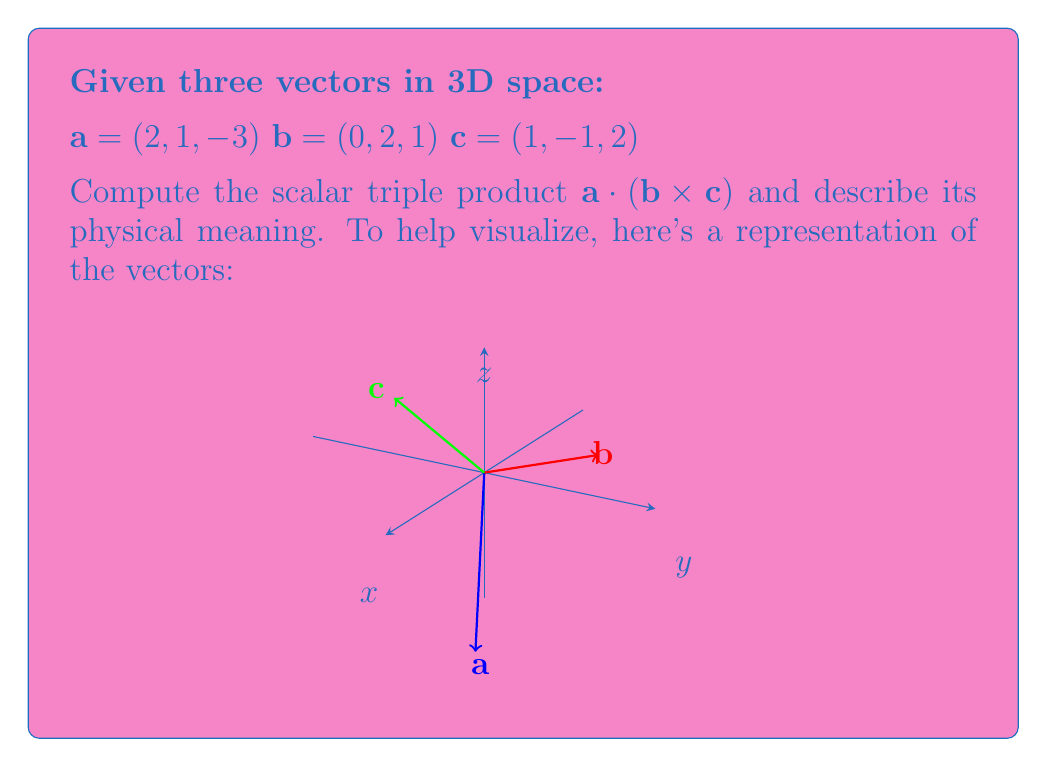Solve this math problem. Let's approach this step-by-step:

1) The scalar triple product is defined as $\mathbf{a} \cdot (\mathbf{b} \times \mathbf{c})$. We need to first calculate the cross product $\mathbf{b} \times \mathbf{c}$.

2) To calculate $\mathbf{b} \times \mathbf{c}$, we use the determinant method:

   $$\mathbf{b} \times \mathbf{c} = \begin{vmatrix} 
   \mathbf{i} & \mathbf{j} & \mathbf{k} \\
   0 & 2 & 1 \\
   1 & -1 & 2
   \end{vmatrix}$$

3) Expanding this determinant:
   $$\mathbf{b} \times \mathbf{c} = (2(2) - 1(-1))\mathbf{i} - (0(2) - 1(1))\mathbf{j} + (0(-1) - 2(1))\mathbf{k}$$

4) Simplifying:
   $$\mathbf{b} \times \mathbf{c} = 5\mathbf{i} - 1\mathbf{j} - 2\mathbf{k} = (5, -1, -2)$$

5) Now, we calculate the dot product of $\mathbf{a}$ with this result:
   $$\mathbf{a} \cdot (\mathbf{b} \times \mathbf{c}) = (2, 1, -3) \cdot (5, -1, -2)$$

6) Computing the dot product:
   $$\mathbf{a} \cdot (\mathbf{b} \times \mathbf{c}) = 2(5) + 1(-1) + (-3)(-2) = 10 - 1 + 6 = 15$$

7) The physical meaning of the scalar triple product is the volume of the parallelepiped formed by the three vectors. The absolute value of the result (15 in this case) gives the volume.

8) If the result is positive, it means $\mathbf{a}$ is on the same side of the plane formed by $\mathbf{b}$ and $\mathbf{c}$ as $\mathbf{b} \times \mathbf{c}$. If negative, it's on the opposite side.
Answer: 15; Volume of parallelepiped formed by vectors, with $\mathbf{a}$ on same side as $\mathbf{b} \times \mathbf{c}$. 